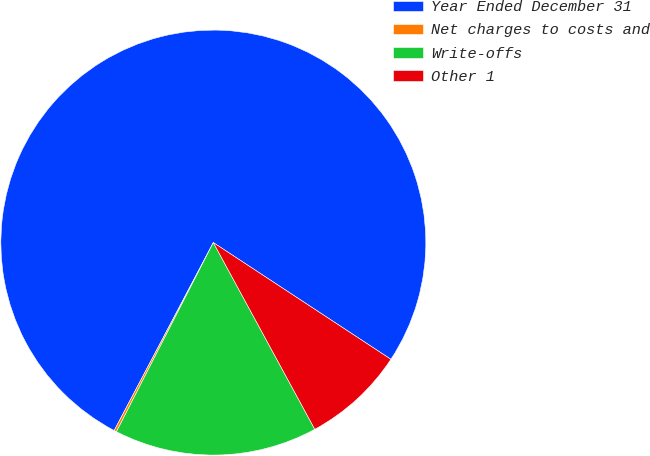<chart> <loc_0><loc_0><loc_500><loc_500><pie_chart><fcel>Year Ended December 31<fcel>Net charges to costs and<fcel>Write-offs<fcel>Other 1<nl><fcel>76.53%<fcel>0.19%<fcel>15.46%<fcel>7.82%<nl></chart> 